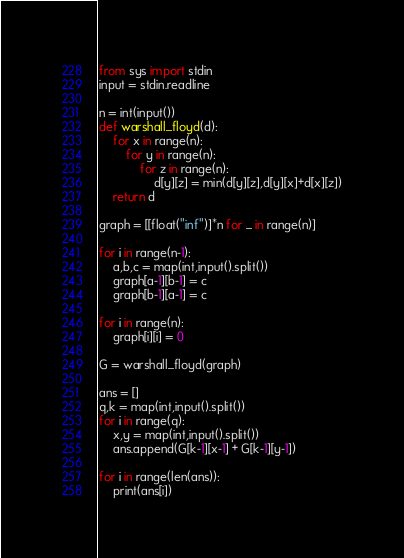Convert code to text. <code><loc_0><loc_0><loc_500><loc_500><_Python_>from sys import stdin
input = stdin.readline

n = int(input())
def warshall_floyd(d):
    for x in range(n):
        for y in range(n):
            for z in range(n):
                d[y][z] = min(d[y][z],d[y][x]+d[x][z])
    return d 

graph = [[float("inf")]*n for _ in range(n)]

for i in range(n-1):
    a,b,c = map(int,input().split())
    graph[a-1][b-1] = c
    graph[b-1][a-1] = c

for i in range(n):
    graph[i][i] = 0

G = warshall_floyd(graph)

ans = []
q,k = map(int,input().split())
for i in range(q):
    x,y = map(int,input().split())
    ans.append(G[k-1][x-1] + G[k-1][y-1])

for i in range(len(ans)):
    print(ans[i])</code> 